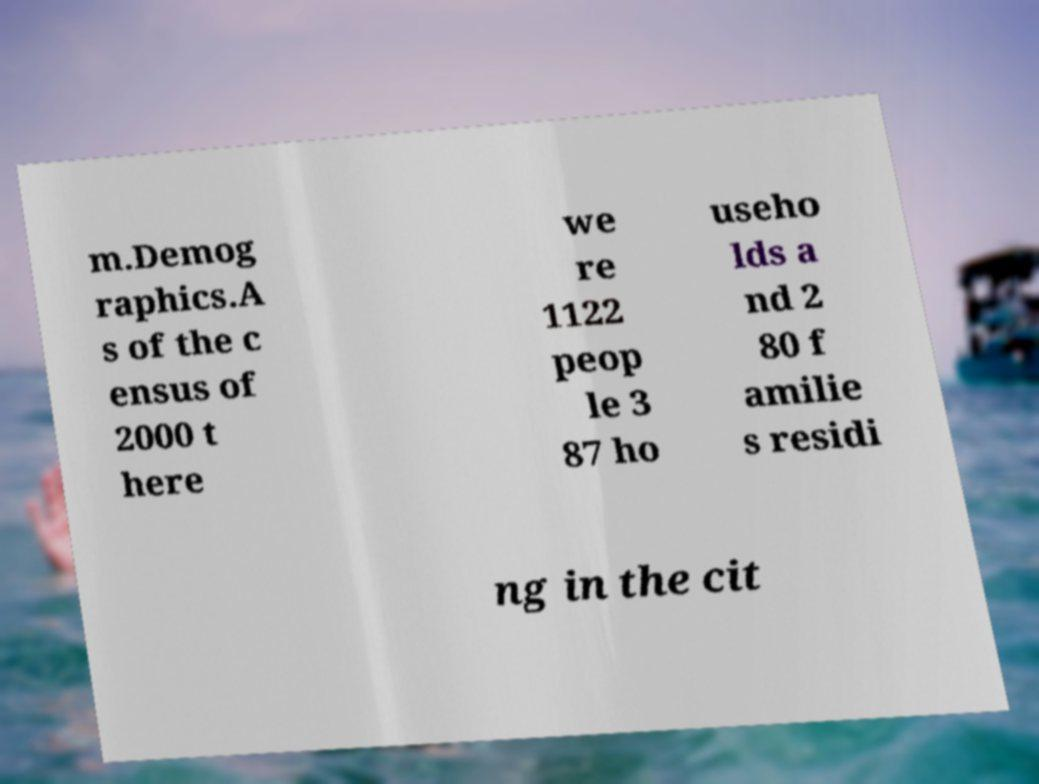Could you assist in decoding the text presented in this image and type it out clearly? m.Demog raphics.A s of the c ensus of 2000 t here we re 1122 peop le 3 87 ho useho lds a nd 2 80 f amilie s residi ng in the cit 